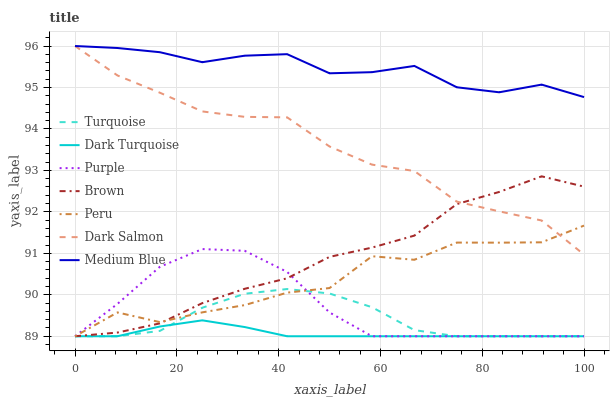Does Turquoise have the minimum area under the curve?
Answer yes or no. No. Does Turquoise have the maximum area under the curve?
Answer yes or no. No. Is Turquoise the smoothest?
Answer yes or no. No. Is Turquoise the roughest?
Answer yes or no. No. Does Medium Blue have the lowest value?
Answer yes or no. No. Does Turquoise have the highest value?
Answer yes or no. No. Is Dark Turquoise less than Medium Blue?
Answer yes or no. Yes. Is Medium Blue greater than Peru?
Answer yes or no. Yes. Does Dark Turquoise intersect Medium Blue?
Answer yes or no. No. 